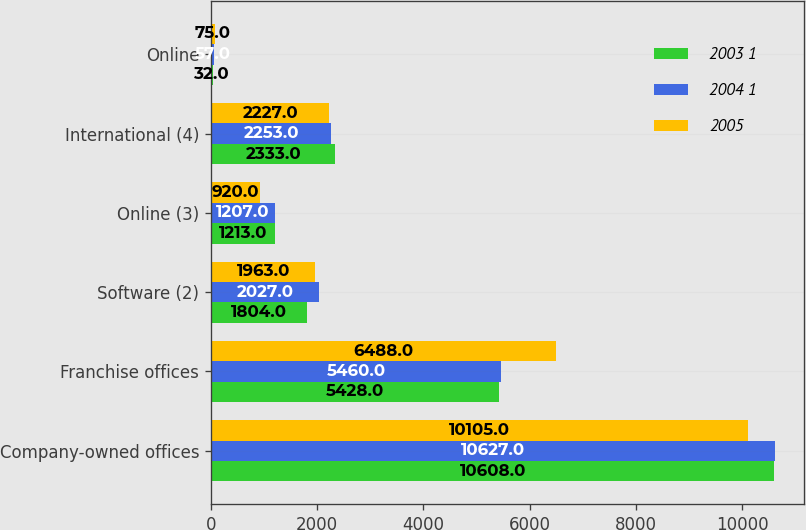<chart> <loc_0><loc_0><loc_500><loc_500><stacked_bar_chart><ecel><fcel>Company-owned offices<fcel>Franchise offices<fcel>Software (2)<fcel>Online (3)<fcel>International (4)<fcel>Online<nl><fcel>2003 1<fcel>10608<fcel>5428<fcel>1804<fcel>1213<fcel>2333<fcel>32<nl><fcel>2004 1<fcel>10627<fcel>5460<fcel>2027<fcel>1207<fcel>2253<fcel>57<nl><fcel>2005<fcel>10105<fcel>6488<fcel>1963<fcel>920<fcel>2227<fcel>75<nl></chart> 